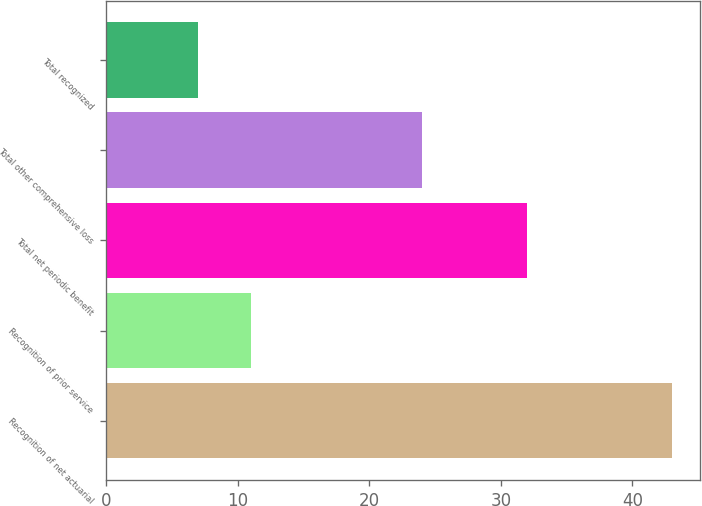Convert chart. <chart><loc_0><loc_0><loc_500><loc_500><bar_chart><fcel>Recognition of net actuarial<fcel>Recognition of prior service<fcel>Total net periodic benefit<fcel>Total other comprehensive loss<fcel>Total recognized<nl><fcel>43<fcel>11<fcel>32<fcel>24<fcel>7<nl></chart> 